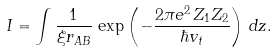Convert formula to latex. <formula><loc_0><loc_0><loc_500><loc_500>I = \int \frac { 1 } { \xi r _ { A B } } \, \exp \left ( - \frac { 2 \pi e ^ { 2 } \, Z _ { 1 } Z _ { 2 } } { \hbar { v } _ { t } } \right ) \, d z .</formula> 